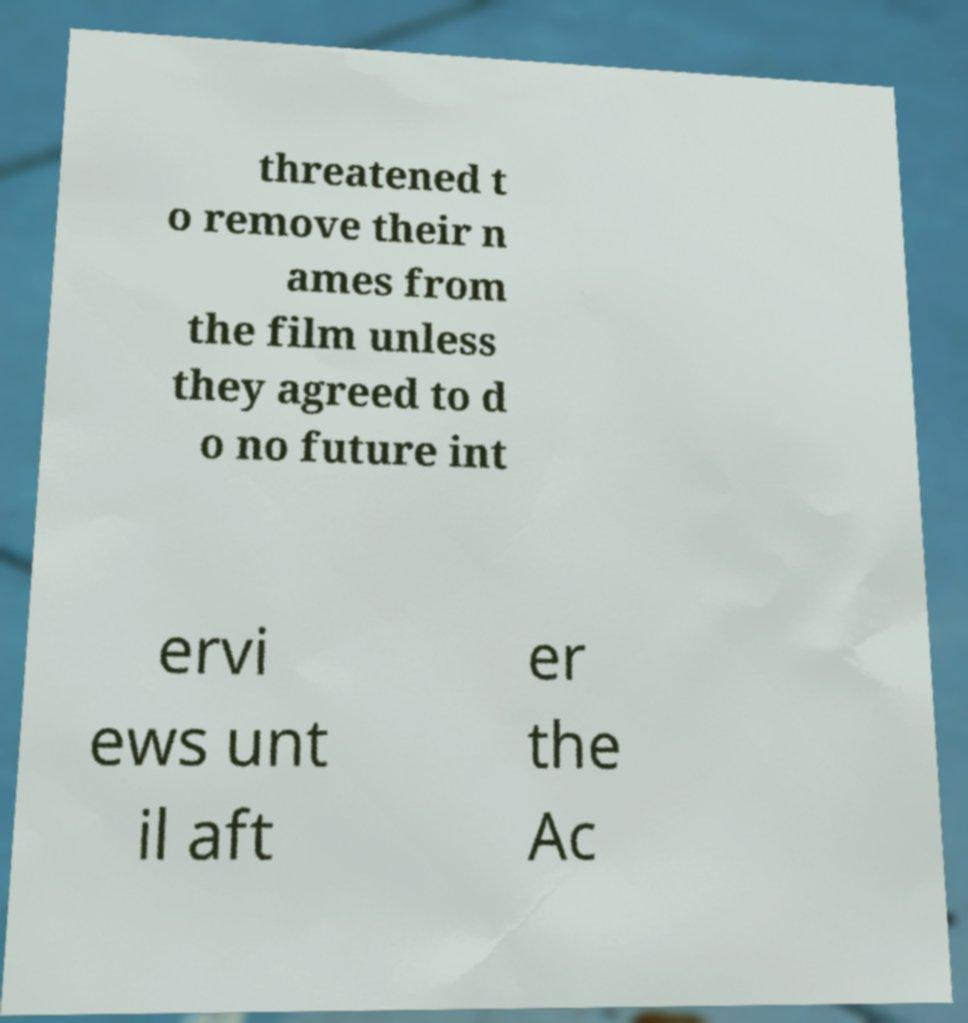Can you accurately transcribe the text from the provided image for me? threatened t o remove their n ames from the film unless they agreed to d o no future int ervi ews unt il aft er the Ac 